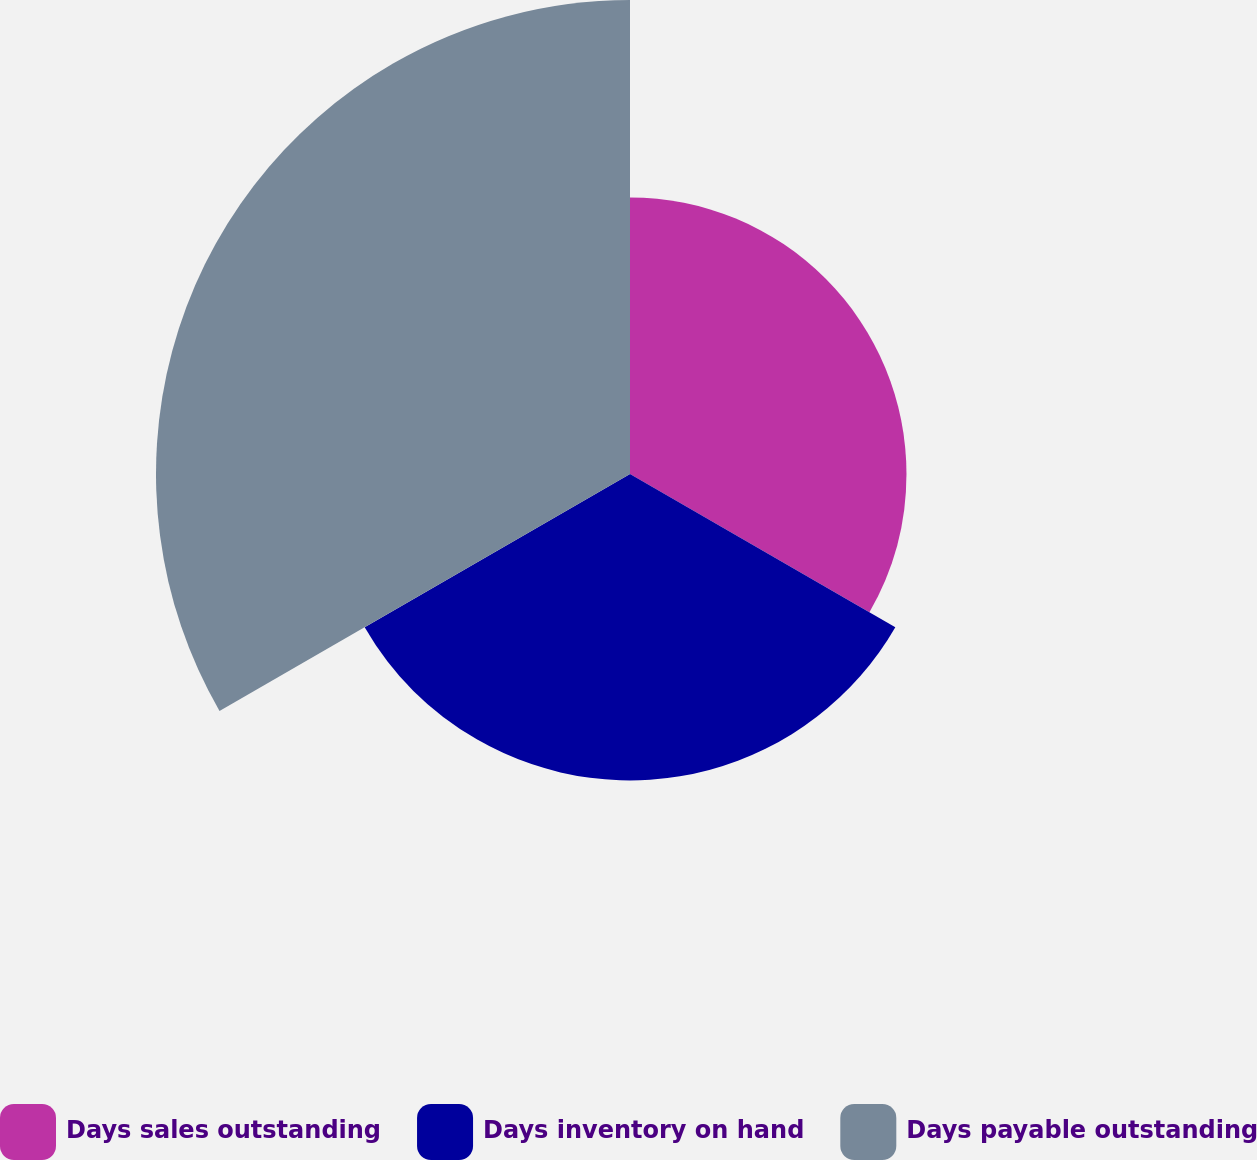Convert chart. <chart><loc_0><loc_0><loc_500><loc_500><pie_chart><fcel>Days sales outstanding<fcel>Days inventory on hand<fcel>Days payable outstanding<nl><fcel>26.16%<fcel>28.99%<fcel>44.85%<nl></chart> 